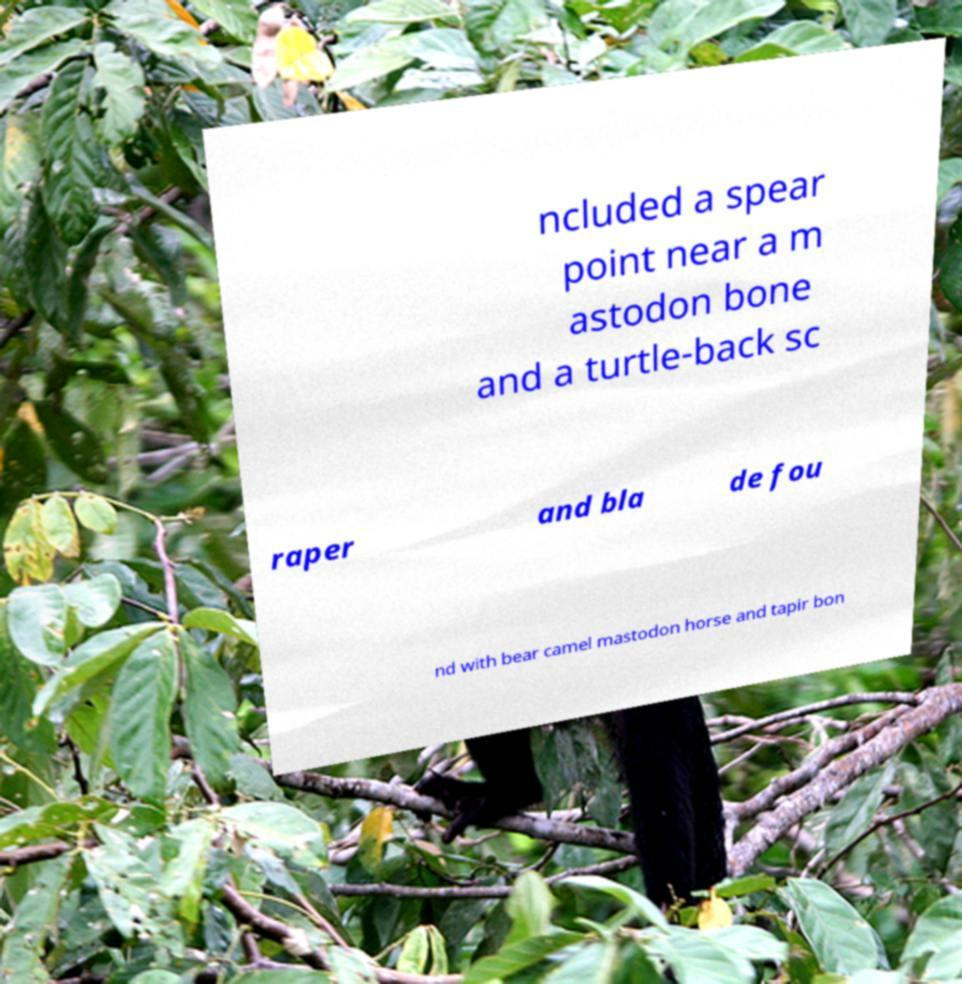Could you extract and type out the text from this image? ncluded a spear point near a m astodon bone and a turtle-back sc raper and bla de fou nd with bear camel mastodon horse and tapir bon 